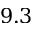<formula> <loc_0><loc_0><loc_500><loc_500>9 . 3</formula> 